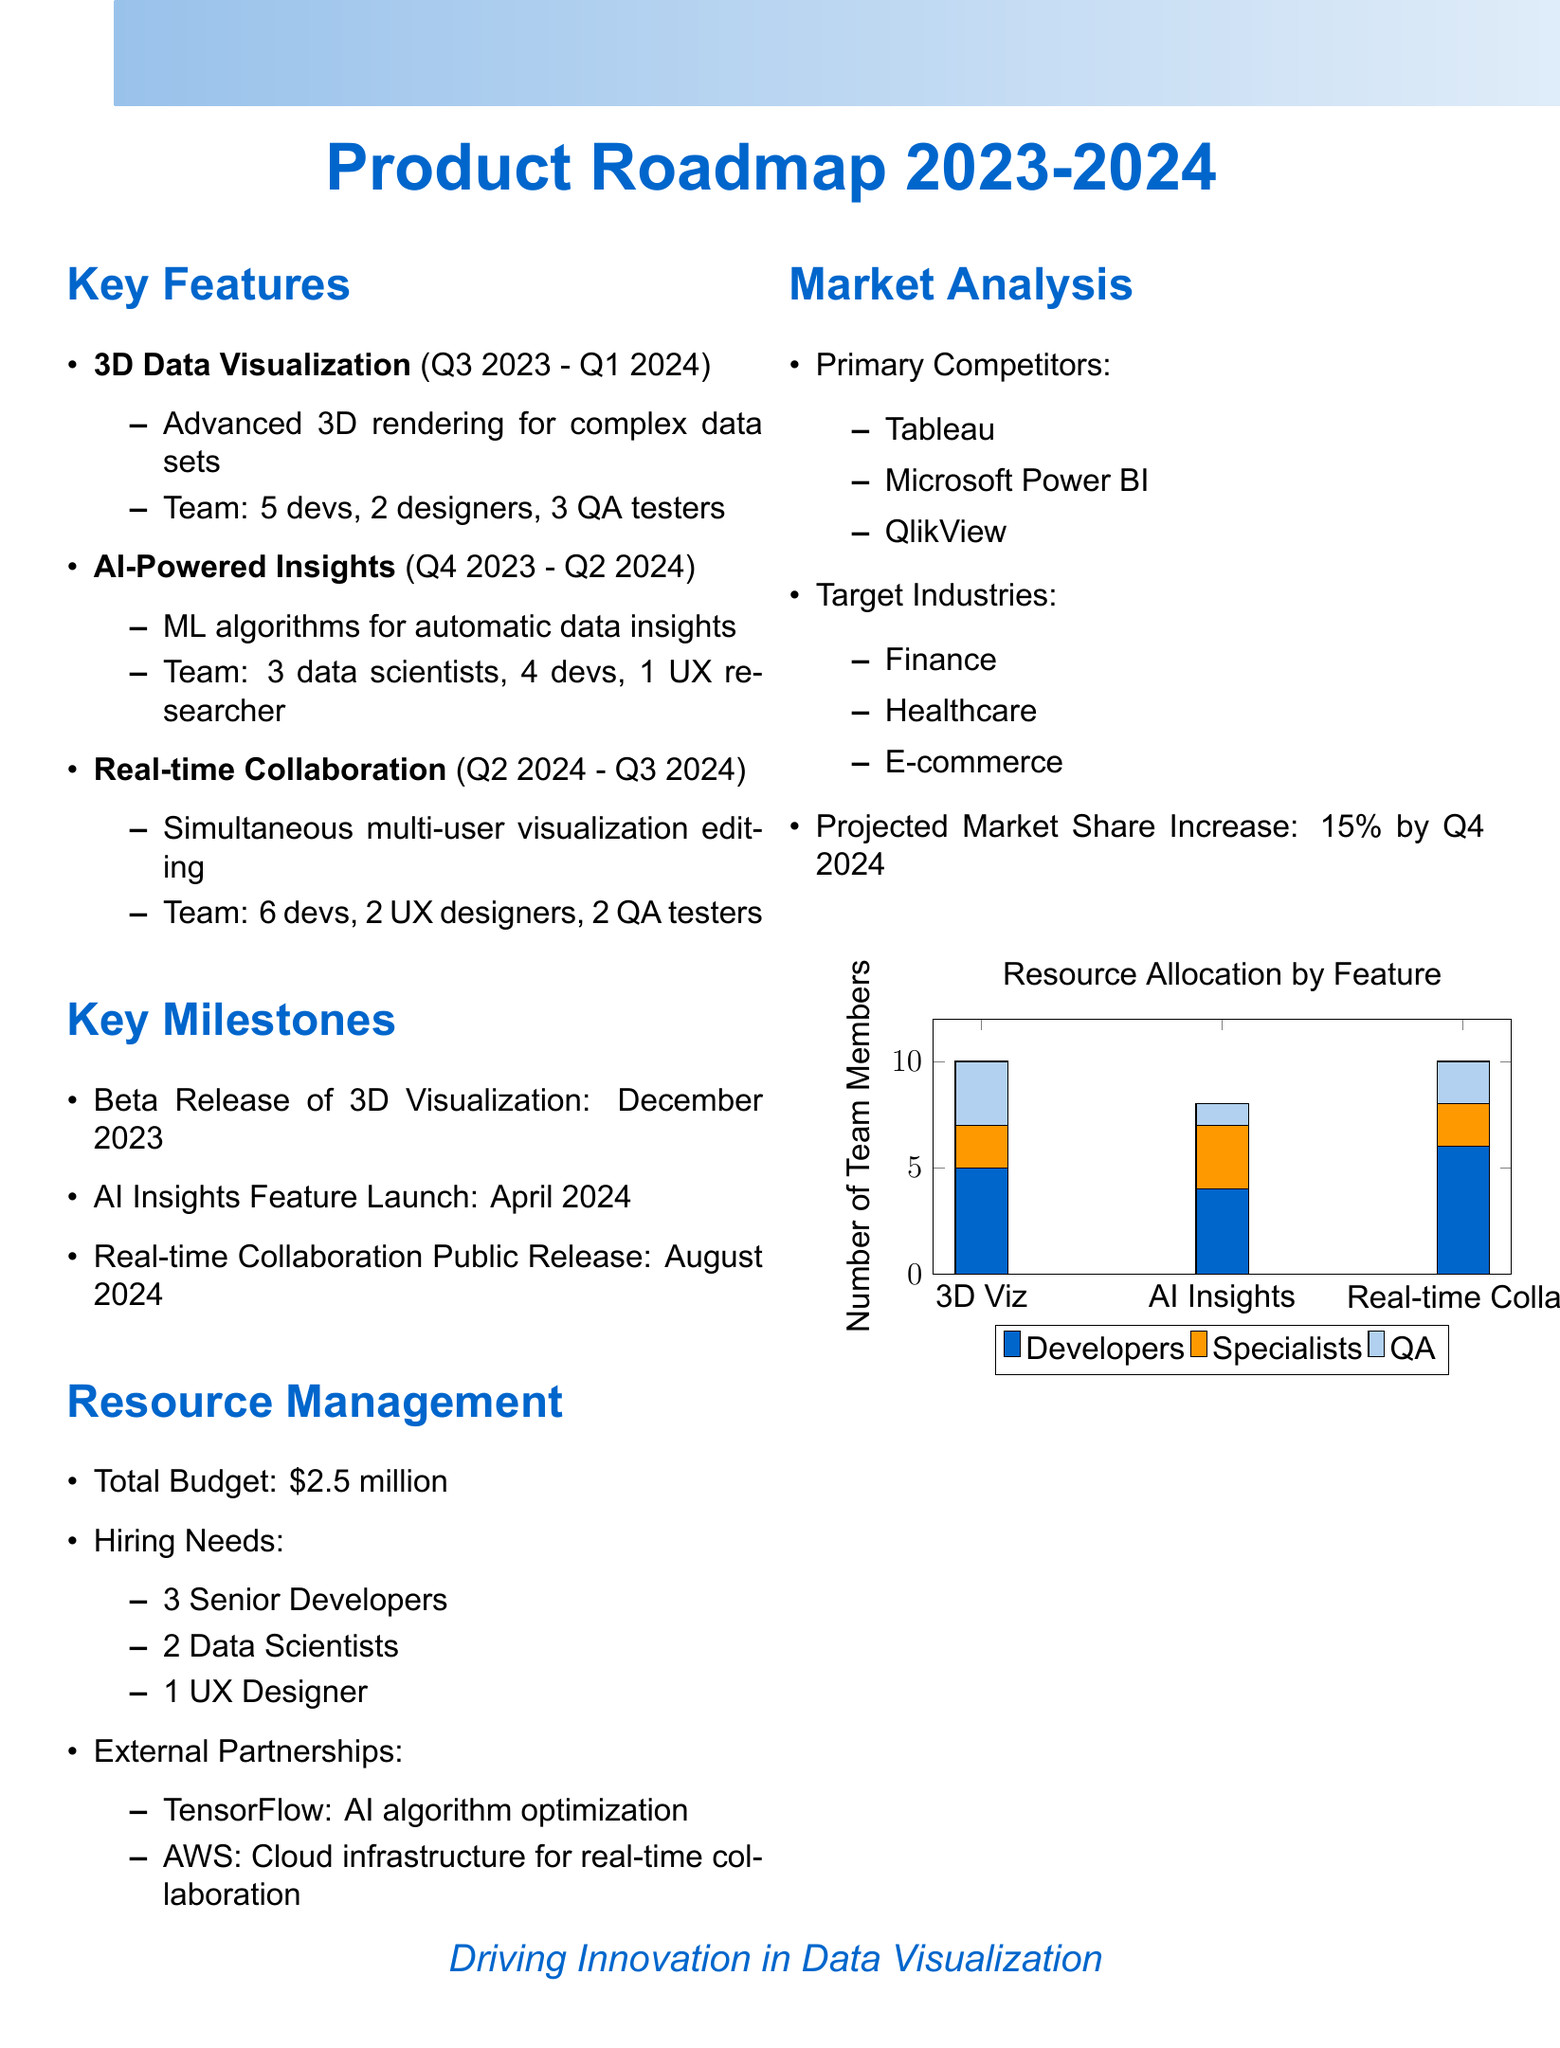What is the timeline for 3D Data Visualization? The timeline for 3D Data Visualization is stated in the document.
Answer: Q3 2023 - Q1 2024 How many developers are allocated to AI-Powered Insights? The resource allocation section lists the number of developers for each feature.
Answer: 4 What is the beta release date for 3D Visualization? Key milestones highlight specific dates associated with the product development timeline.
Answer: December 2023 Which external partner is associated with AI algorithm optimization? The external partnerships section identifies partners and their purposes.
Answer: TensorFlow What is the total budget for resource management? Total budget figures are provided under the resource management section.
Answer: $2.5 million How many UX designers are needed for hiring? The hiring needs section specifies the number of UX designers required for upcoming developments.
Answer: 1 What feature is scheduled for public release in August 2024? Key milestones outline when significant features will be released to the public.
Answer: Real-time Collaboration What is the projected market share increase by Q4 2024? Market analysis describes expectations for market performance.
Answer: 15% 